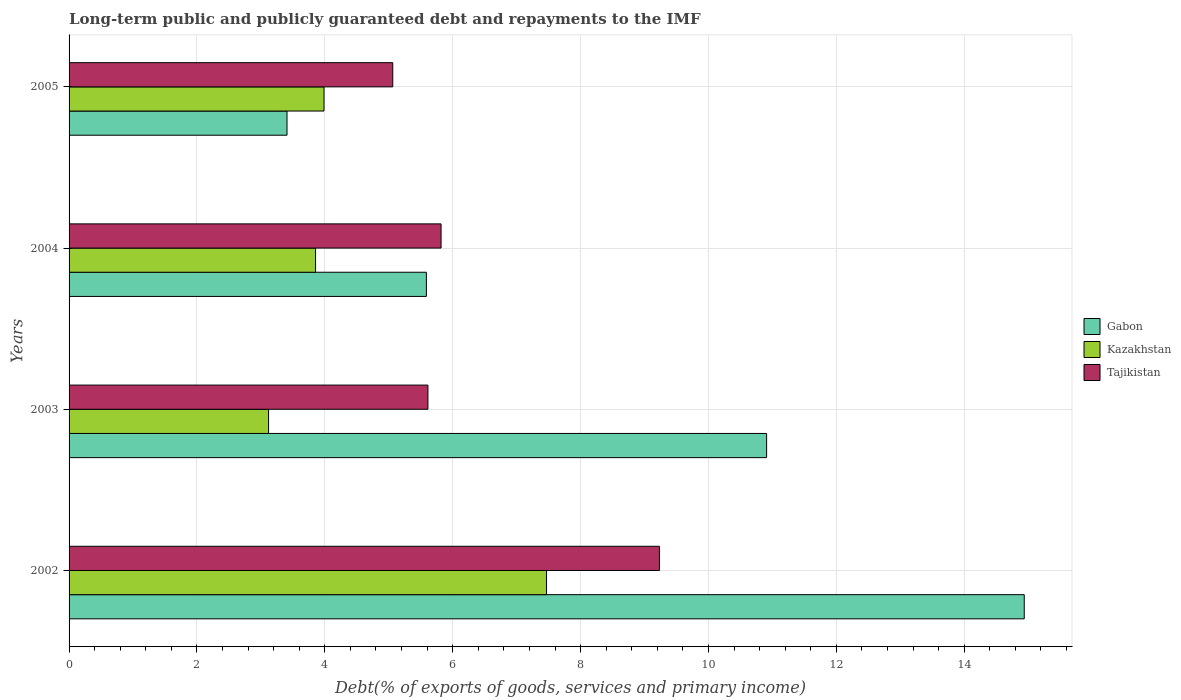Are the number of bars on each tick of the Y-axis equal?
Your response must be concise. Yes. How many bars are there on the 4th tick from the top?
Your answer should be compact. 3. How many bars are there on the 4th tick from the bottom?
Your answer should be very brief. 3. What is the debt and repayments in Kazakhstan in 2002?
Offer a terse response. 7.47. Across all years, what is the maximum debt and repayments in Gabon?
Your answer should be very brief. 14.94. Across all years, what is the minimum debt and repayments in Tajikistan?
Provide a succinct answer. 5.06. In which year was the debt and repayments in Gabon maximum?
Keep it short and to the point. 2002. What is the total debt and repayments in Gabon in the graph?
Keep it short and to the point. 34.84. What is the difference between the debt and repayments in Kazakhstan in 2002 and that in 2004?
Make the answer very short. 3.61. What is the difference between the debt and repayments in Gabon in 2005 and the debt and repayments in Kazakhstan in 2002?
Offer a terse response. -4.06. What is the average debt and repayments in Tajikistan per year?
Your answer should be very brief. 6.43. In the year 2005, what is the difference between the debt and repayments in Kazakhstan and debt and repayments in Gabon?
Keep it short and to the point. 0.58. In how many years, is the debt and repayments in Gabon greater than 2.4 %?
Ensure brevity in your answer.  4. What is the ratio of the debt and repayments in Gabon in 2004 to that in 2005?
Make the answer very short. 1.64. Is the difference between the debt and repayments in Kazakhstan in 2002 and 2005 greater than the difference between the debt and repayments in Gabon in 2002 and 2005?
Your answer should be compact. No. What is the difference between the highest and the second highest debt and repayments in Kazakhstan?
Provide a succinct answer. 3.48. What is the difference between the highest and the lowest debt and repayments in Kazakhstan?
Give a very brief answer. 4.35. In how many years, is the debt and repayments in Kazakhstan greater than the average debt and repayments in Kazakhstan taken over all years?
Offer a very short reply. 1. Is the sum of the debt and repayments in Kazakhstan in 2002 and 2005 greater than the maximum debt and repayments in Gabon across all years?
Your answer should be very brief. No. What does the 1st bar from the top in 2004 represents?
Give a very brief answer. Tajikistan. What does the 3rd bar from the bottom in 2004 represents?
Offer a terse response. Tajikistan. Are all the bars in the graph horizontal?
Your answer should be very brief. Yes. How many years are there in the graph?
Provide a succinct answer. 4. Are the values on the major ticks of X-axis written in scientific E-notation?
Offer a very short reply. No. Does the graph contain any zero values?
Offer a terse response. No. How are the legend labels stacked?
Offer a very short reply. Vertical. What is the title of the graph?
Give a very brief answer. Long-term public and publicly guaranteed debt and repayments to the IMF. Does "Austria" appear as one of the legend labels in the graph?
Your answer should be compact. No. What is the label or title of the X-axis?
Provide a succinct answer. Debt(% of exports of goods, services and primary income). What is the Debt(% of exports of goods, services and primary income) in Gabon in 2002?
Give a very brief answer. 14.94. What is the Debt(% of exports of goods, services and primary income) of Kazakhstan in 2002?
Offer a very short reply. 7.47. What is the Debt(% of exports of goods, services and primary income) of Tajikistan in 2002?
Keep it short and to the point. 9.23. What is the Debt(% of exports of goods, services and primary income) of Gabon in 2003?
Your answer should be very brief. 10.91. What is the Debt(% of exports of goods, services and primary income) of Kazakhstan in 2003?
Your answer should be compact. 3.12. What is the Debt(% of exports of goods, services and primary income) of Tajikistan in 2003?
Provide a short and direct response. 5.61. What is the Debt(% of exports of goods, services and primary income) of Gabon in 2004?
Your answer should be very brief. 5.59. What is the Debt(% of exports of goods, services and primary income) in Kazakhstan in 2004?
Offer a very short reply. 3.86. What is the Debt(% of exports of goods, services and primary income) of Tajikistan in 2004?
Make the answer very short. 5.82. What is the Debt(% of exports of goods, services and primary income) in Gabon in 2005?
Provide a short and direct response. 3.41. What is the Debt(% of exports of goods, services and primary income) in Kazakhstan in 2005?
Your answer should be very brief. 3.99. What is the Debt(% of exports of goods, services and primary income) in Tajikistan in 2005?
Provide a short and direct response. 5.06. Across all years, what is the maximum Debt(% of exports of goods, services and primary income) in Gabon?
Offer a very short reply. 14.94. Across all years, what is the maximum Debt(% of exports of goods, services and primary income) of Kazakhstan?
Provide a succinct answer. 7.47. Across all years, what is the maximum Debt(% of exports of goods, services and primary income) of Tajikistan?
Your response must be concise. 9.23. Across all years, what is the minimum Debt(% of exports of goods, services and primary income) of Gabon?
Provide a succinct answer. 3.41. Across all years, what is the minimum Debt(% of exports of goods, services and primary income) in Kazakhstan?
Offer a very short reply. 3.12. Across all years, what is the minimum Debt(% of exports of goods, services and primary income) in Tajikistan?
Your answer should be compact. 5.06. What is the total Debt(% of exports of goods, services and primary income) of Gabon in the graph?
Give a very brief answer. 34.84. What is the total Debt(% of exports of goods, services and primary income) of Kazakhstan in the graph?
Make the answer very short. 18.43. What is the total Debt(% of exports of goods, services and primary income) of Tajikistan in the graph?
Your answer should be very brief. 25.73. What is the difference between the Debt(% of exports of goods, services and primary income) in Gabon in 2002 and that in 2003?
Give a very brief answer. 4.03. What is the difference between the Debt(% of exports of goods, services and primary income) of Kazakhstan in 2002 and that in 2003?
Offer a terse response. 4.35. What is the difference between the Debt(% of exports of goods, services and primary income) in Tajikistan in 2002 and that in 2003?
Offer a very short reply. 3.62. What is the difference between the Debt(% of exports of goods, services and primary income) in Gabon in 2002 and that in 2004?
Your answer should be compact. 9.35. What is the difference between the Debt(% of exports of goods, services and primary income) in Kazakhstan in 2002 and that in 2004?
Offer a very short reply. 3.61. What is the difference between the Debt(% of exports of goods, services and primary income) in Tajikistan in 2002 and that in 2004?
Your answer should be compact. 3.42. What is the difference between the Debt(% of exports of goods, services and primary income) in Gabon in 2002 and that in 2005?
Ensure brevity in your answer.  11.53. What is the difference between the Debt(% of exports of goods, services and primary income) in Kazakhstan in 2002 and that in 2005?
Ensure brevity in your answer.  3.48. What is the difference between the Debt(% of exports of goods, services and primary income) of Tajikistan in 2002 and that in 2005?
Your answer should be compact. 4.17. What is the difference between the Debt(% of exports of goods, services and primary income) of Gabon in 2003 and that in 2004?
Provide a short and direct response. 5.32. What is the difference between the Debt(% of exports of goods, services and primary income) of Kazakhstan in 2003 and that in 2004?
Keep it short and to the point. -0.73. What is the difference between the Debt(% of exports of goods, services and primary income) in Tajikistan in 2003 and that in 2004?
Provide a succinct answer. -0.21. What is the difference between the Debt(% of exports of goods, services and primary income) of Gabon in 2003 and that in 2005?
Give a very brief answer. 7.5. What is the difference between the Debt(% of exports of goods, services and primary income) of Kazakhstan in 2003 and that in 2005?
Provide a short and direct response. -0.87. What is the difference between the Debt(% of exports of goods, services and primary income) in Tajikistan in 2003 and that in 2005?
Your response must be concise. 0.55. What is the difference between the Debt(% of exports of goods, services and primary income) in Gabon in 2004 and that in 2005?
Provide a short and direct response. 2.18. What is the difference between the Debt(% of exports of goods, services and primary income) of Kazakhstan in 2004 and that in 2005?
Provide a short and direct response. -0.13. What is the difference between the Debt(% of exports of goods, services and primary income) in Tajikistan in 2004 and that in 2005?
Make the answer very short. 0.76. What is the difference between the Debt(% of exports of goods, services and primary income) of Gabon in 2002 and the Debt(% of exports of goods, services and primary income) of Kazakhstan in 2003?
Provide a succinct answer. 11.82. What is the difference between the Debt(% of exports of goods, services and primary income) of Gabon in 2002 and the Debt(% of exports of goods, services and primary income) of Tajikistan in 2003?
Provide a short and direct response. 9.33. What is the difference between the Debt(% of exports of goods, services and primary income) of Kazakhstan in 2002 and the Debt(% of exports of goods, services and primary income) of Tajikistan in 2003?
Offer a very short reply. 1.85. What is the difference between the Debt(% of exports of goods, services and primary income) in Gabon in 2002 and the Debt(% of exports of goods, services and primary income) in Kazakhstan in 2004?
Provide a succinct answer. 11.08. What is the difference between the Debt(% of exports of goods, services and primary income) in Gabon in 2002 and the Debt(% of exports of goods, services and primary income) in Tajikistan in 2004?
Offer a very short reply. 9.12. What is the difference between the Debt(% of exports of goods, services and primary income) in Kazakhstan in 2002 and the Debt(% of exports of goods, services and primary income) in Tajikistan in 2004?
Your answer should be very brief. 1.65. What is the difference between the Debt(% of exports of goods, services and primary income) of Gabon in 2002 and the Debt(% of exports of goods, services and primary income) of Kazakhstan in 2005?
Ensure brevity in your answer.  10.95. What is the difference between the Debt(% of exports of goods, services and primary income) of Gabon in 2002 and the Debt(% of exports of goods, services and primary income) of Tajikistan in 2005?
Give a very brief answer. 9.88. What is the difference between the Debt(% of exports of goods, services and primary income) in Kazakhstan in 2002 and the Debt(% of exports of goods, services and primary income) in Tajikistan in 2005?
Ensure brevity in your answer.  2.4. What is the difference between the Debt(% of exports of goods, services and primary income) of Gabon in 2003 and the Debt(% of exports of goods, services and primary income) of Kazakhstan in 2004?
Your response must be concise. 7.05. What is the difference between the Debt(% of exports of goods, services and primary income) in Gabon in 2003 and the Debt(% of exports of goods, services and primary income) in Tajikistan in 2004?
Your answer should be very brief. 5.09. What is the difference between the Debt(% of exports of goods, services and primary income) in Kazakhstan in 2003 and the Debt(% of exports of goods, services and primary income) in Tajikistan in 2004?
Keep it short and to the point. -2.7. What is the difference between the Debt(% of exports of goods, services and primary income) in Gabon in 2003 and the Debt(% of exports of goods, services and primary income) in Kazakhstan in 2005?
Ensure brevity in your answer.  6.92. What is the difference between the Debt(% of exports of goods, services and primary income) in Gabon in 2003 and the Debt(% of exports of goods, services and primary income) in Tajikistan in 2005?
Offer a terse response. 5.85. What is the difference between the Debt(% of exports of goods, services and primary income) of Kazakhstan in 2003 and the Debt(% of exports of goods, services and primary income) of Tajikistan in 2005?
Your answer should be very brief. -1.94. What is the difference between the Debt(% of exports of goods, services and primary income) in Gabon in 2004 and the Debt(% of exports of goods, services and primary income) in Kazakhstan in 2005?
Keep it short and to the point. 1.6. What is the difference between the Debt(% of exports of goods, services and primary income) in Gabon in 2004 and the Debt(% of exports of goods, services and primary income) in Tajikistan in 2005?
Offer a terse response. 0.53. What is the difference between the Debt(% of exports of goods, services and primary income) of Kazakhstan in 2004 and the Debt(% of exports of goods, services and primary income) of Tajikistan in 2005?
Your answer should be very brief. -1.21. What is the average Debt(% of exports of goods, services and primary income) in Gabon per year?
Offer a terse response. 8.71. What is the average Debt(% of exports of goods, services and primary income) in Kazakhstan per year?
Provide a short and direct response. 4.61. What is the average Debt(% of exports of goods, services and primary income) of Tajikistan per year?
Offer a very short reply. 6.43. In the year 2002, what is the difference between the Debt(% of exports of goods, services and primary income) in Gabon and Debt(% of exports of goods, services and primary income) in Kazakhstan?
Your answer should be very brief. 7.47. In the year 2002, what is the difference between the Debt(% of exports of goods, services and primary income) in Gabon and Debt(% of exports of goods, services and primary income) in Tajikistan?
Offer a terse response. 5.71. In the year 2002, what is the difference between the Debt(% of exports of goods, services and primary income) in Kazakhstan and Debt(% of exports of goods, services and primary income) in Tajikistan?
Provide a succinct answer. -1.77. In the year 2003, what is the difference between the Debt(% of exports of goods, services and primary income) of Gabon and Debt(% of exports of goods, services and primary income) of Kazakhstan?
Provide a succinct answer. 7.79. In the year 2003, what is the difference between the Debt(% of exports of goods, services and primary income) of Gabon and Debt(% of exports of goods, services and primary income) of Tajikistan?
Make the answer very short. 5.3. In the year 2003, what is the difference between the Debt(% of exports of goods, services and primary income) of Kazakhstan and Debt(% of exports of goods, services and primary income) of Tajikistan?
Offer a very short reply. -2.49. In the year 2004, what is the difference between the Debt(% of exports of goods, services and primary income) in Gabon and Debt(% of exports of goods, services and primary income) in Kazakhstan?
Offer a very short reply. 1.73. In the year 2004, what is the difference between the Debt(% of exports of goods, services and primary income) in Gabon and Debt(% of exports of goods, services and primary income) in Tajikistan?
Provide a succinct answer. -0.23. In the year 2004, what is the difference between the Debt(% of exports of goods, services and primary income) of Kazakhstan and Debt(% of exports of goods, services and primary income) of Tajikistan?
Keep it short and to the point. -1.96. In the year 2005, what is the difference between the Debt(% of exports of goods, services and primary income) in Gabon and Debt(% of exports of goods, services and primary income) in Kazakhstan?
Provide a short and direct response. -0.58. In the year 2005, what is the difference between the Debt(% of exports of goods, services and primary income) of Gabon and Debt(% of exports of goods, services and primary income) of Tajikistan?
Give a very brief answer. -1.65. In the year 2005, what is the difference between the Debt(% of exports of goods, services and primary income) of Kazakhstan and Debt(% of exports of goods, services and primary income) of Tajikistan?
Your answer should be compact. -1.08. What is the ratio of the Debt(% of exports of goods, services and primary income) in Gabon in 2002 to that in 2003?
Your response must be concise. 1.37. What is the ratio of the Debt(% of exports of goods, services and primary income) of Kazakhstan in 2002 to that in 2003?
Offer a terse response. 2.39. What is the ratio of the Debt(% of exports of goods, services and primary income) of Tajikistan in 2002 to that in 2003?
Offer a terse response. 1.65. What is the ratio of the Debt(% of exports of goods, services and primary income) in Gabon in 2002 to that in 2004?
Provide a succinct answer. 2.67. What is the ratio of the Debt(% of exports of goods, services and primary income) in Kazakhstan in 2002 to that in 2004?
Provide a succinct answer. 1.94. What is the ratio of the Debt(% of exports of goods, services and primary income) in Tajikistan in 2002 to that in 2004?
Your response must be concise. 1.59. What is the ratio of the Debt(% of exports of goods, services and primary income) in Gabon in 2002 to that in 2005?
Your answer should be compact. 4.38. What is the ratio of the Debt(% of exports of goods, services and primary income) of Kazakhstan in 2002 to that in 2005?
Provide a succinct answer. 1.87. What is the ratio of the Debt(% of exports of goods, services and primary income) in Tajikistan in 2002 to that in 2005?
Ensure brevity in your answer.  1.82. What is the ratio of the Debt(% of exports of goods, services and primary income) in Gabon in 2003 to that in 2004?
Your response must be concise. 1.95. What is the ratio of the Debt(% of exports of goods, services and primary income) of Kazakhstan in 2003 to that in 2004?
Give a very brief answer. 0.81. What is the ratio of the Debt(% of exports of goods, services and primary income) in Tajikistan in 2003 to that in 2004?
Give a very brief answer. 0.96. What is the ratio of the Debt(% of exports of goods, services and primary income) in Gabon in 2003 to that in 2005?
Offer a very short reply. 3.2. What is the ratio of the Debt(% of exports of goods, services and primary income) in Kazakhstan in 2003 to that in 2005?
Give a very brief answer. 0.78. What is the ratio of the Debt(% of exports of goods, services and primary income) in Tajikistan in 2003 to that in 2005?
Your response must be concise. 1.11. What is the ratio of the Debt(% of exports of goods, services and primary income) in Gabon in 2004 to that in 2005?
Make the answer very short. 1.64. What is the ratio of the Debt(% of exports of goods, services and primary income) of Kazakhstan in 2004 to that in 2005?
Your response must be concise. 0.97. What is the ratio of the Debt(% of exports of goods, services and primary income) in Tajikistan in 2004 to that in 2005?
Offer a terse response. 1.15. What is the difference between the highest and the second highest Debt(% of exports of goods, services and primary income) of Gabon?
Your answer should be compact. 4.03. What is the difference between the highest and the second highest Debt(% of exports of goods, services and primary income) of Kazakhstan?
Offer a very short reply. 3.48. What is the difference between the highest and the second highest Debt(% of exports of goods, services and primary income) of Tajikistan?
Provide a succinct answer. 3.42. What is the difference between the highest and the lowest Debt(% of exports of goods, services and primary income) of Gabon?
Provide a succinct answer. 11.53. What is the difference between the highest and the lowest Debt(% of exports of goods, services and primary income) of Kazakhstan?
Provide a short and direct response. 4.35. What is the difference between the highest and the lowest Debt(% of exports of goods, services and primary income) in Tajikistan?
Your answer should be compact. 4.17. 